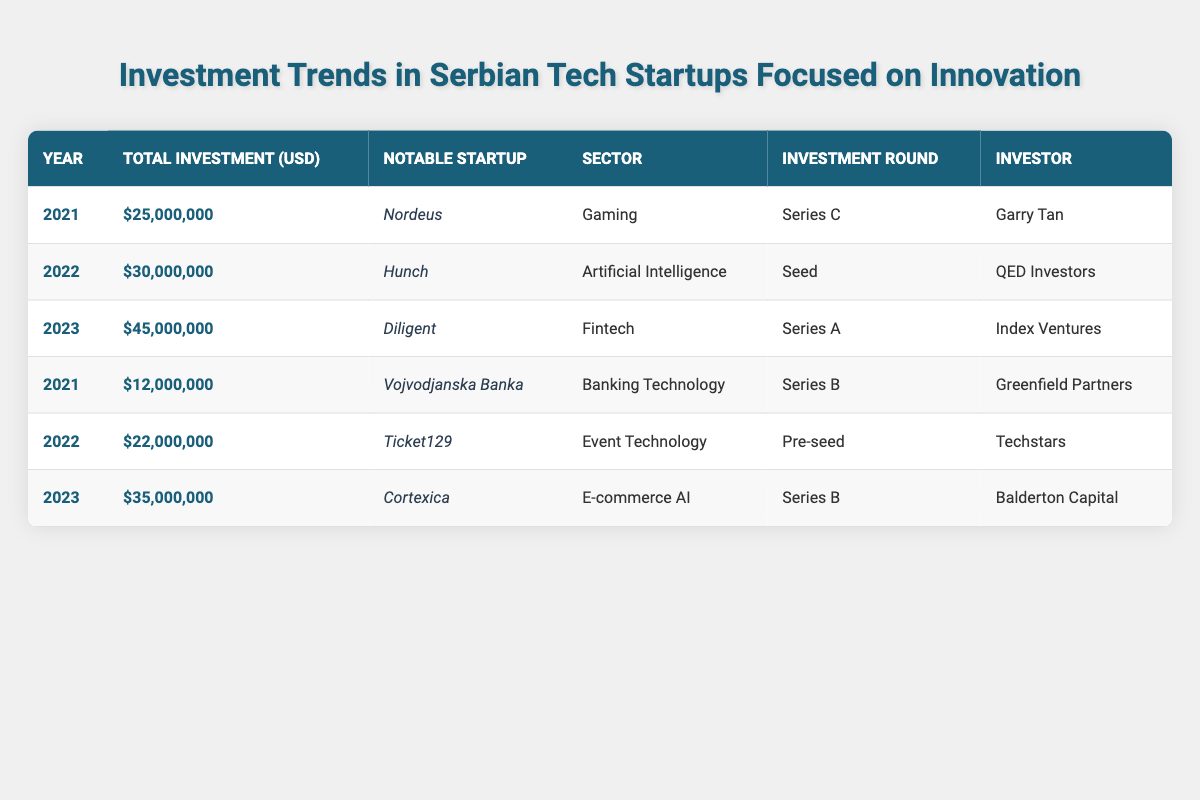What was the total investment in Serbian tech startups in 2021? In 2021, the total investments listed are $25,000,000 (Nordeus) and $12,000,000 (Vojvodjanska Banka). Adding these two amounts gives us $25,000,000 + $12,000,000 = $37,000,000.
Answer: $37,000,000 Which notable startup received the highest investment in 2023? In 2023, Diligent received $45,000,000, which is higher than the other listed startup Cortexica that received $35,000,000.
Answer: Diligent How much investment was made in Artificial Intelligence startups across the years? In 2022, Hunch received $30,000,000 for Artificial Intelligence. No other investment in this sector is mentioned in the other years. Therefore, the total is $30,000,000.
Answer: $30,000,000 What is the difference in total investment between 2022 and 2023? Total investment in 2022 is $30,000,000 + $22,000,000 = $52,000,000. Total investment in 2023 is $45,000,000 + $35,000,000 = $80,000,000. The difference is $80,000,000 - $52,000,000 = $28,000,000.
Answer: $28,000,000 Did any startups receive a pre-seed investment round in 2021? The table shows that Ticket129 received a pre-seed investment round in 2022, and there are no startups listed for 2021 with that round. Thus, the answer is no.
Answer: No What was the average investment amount for the three years presented? The total investment across the three years is $37,000,000 (2021) + $52,000,000 (2022) + $80,000,000 (2023) = $169,000,000. There are six data points, so the average is $169,000,000 / 6 = $28,166,666.67, approximately $28,167,000.
Answer: $28,167,000 Which sector had the most startups featured in the investment data? The sectors represented are Gaming (1), AI (1), Fintech (1), Banking Technology (1), and Event Technology (1). Each sector has one listed startup, so there's no sector that has more than one startup featured.
Answer: No sector has multiple startups What was the total investment in Series B rounds across all years? In 2021, Vojvodjanska Banka received $12,000,000 in Series B. In 2023, Cortexica received $35,000,000 in Series B as well. Therefore, the total for Series B rounds is $12,000,000 + $35,000,000 = $47,000,000.
Answer: $47,000,000 Is there a consistent year-over-year growth in the total investment amount? 2021 total is $37,000,000, 2022 total is $52,000,000, and 2023 total is $80,000,000. To check growth: ($52,000,000 - $37,000,000) = $15,000,000 growth from 2021 to 2022, and ($80,000,000 - $52,000,000) = $28,000,000 growth from 2022 to 2023, indicating growth is present for both years.
Answer: Yes What was the investment round for the notable startup "Nordeus"? According to the table, Nordeus had a Series C investment round.
Answer: Series C 